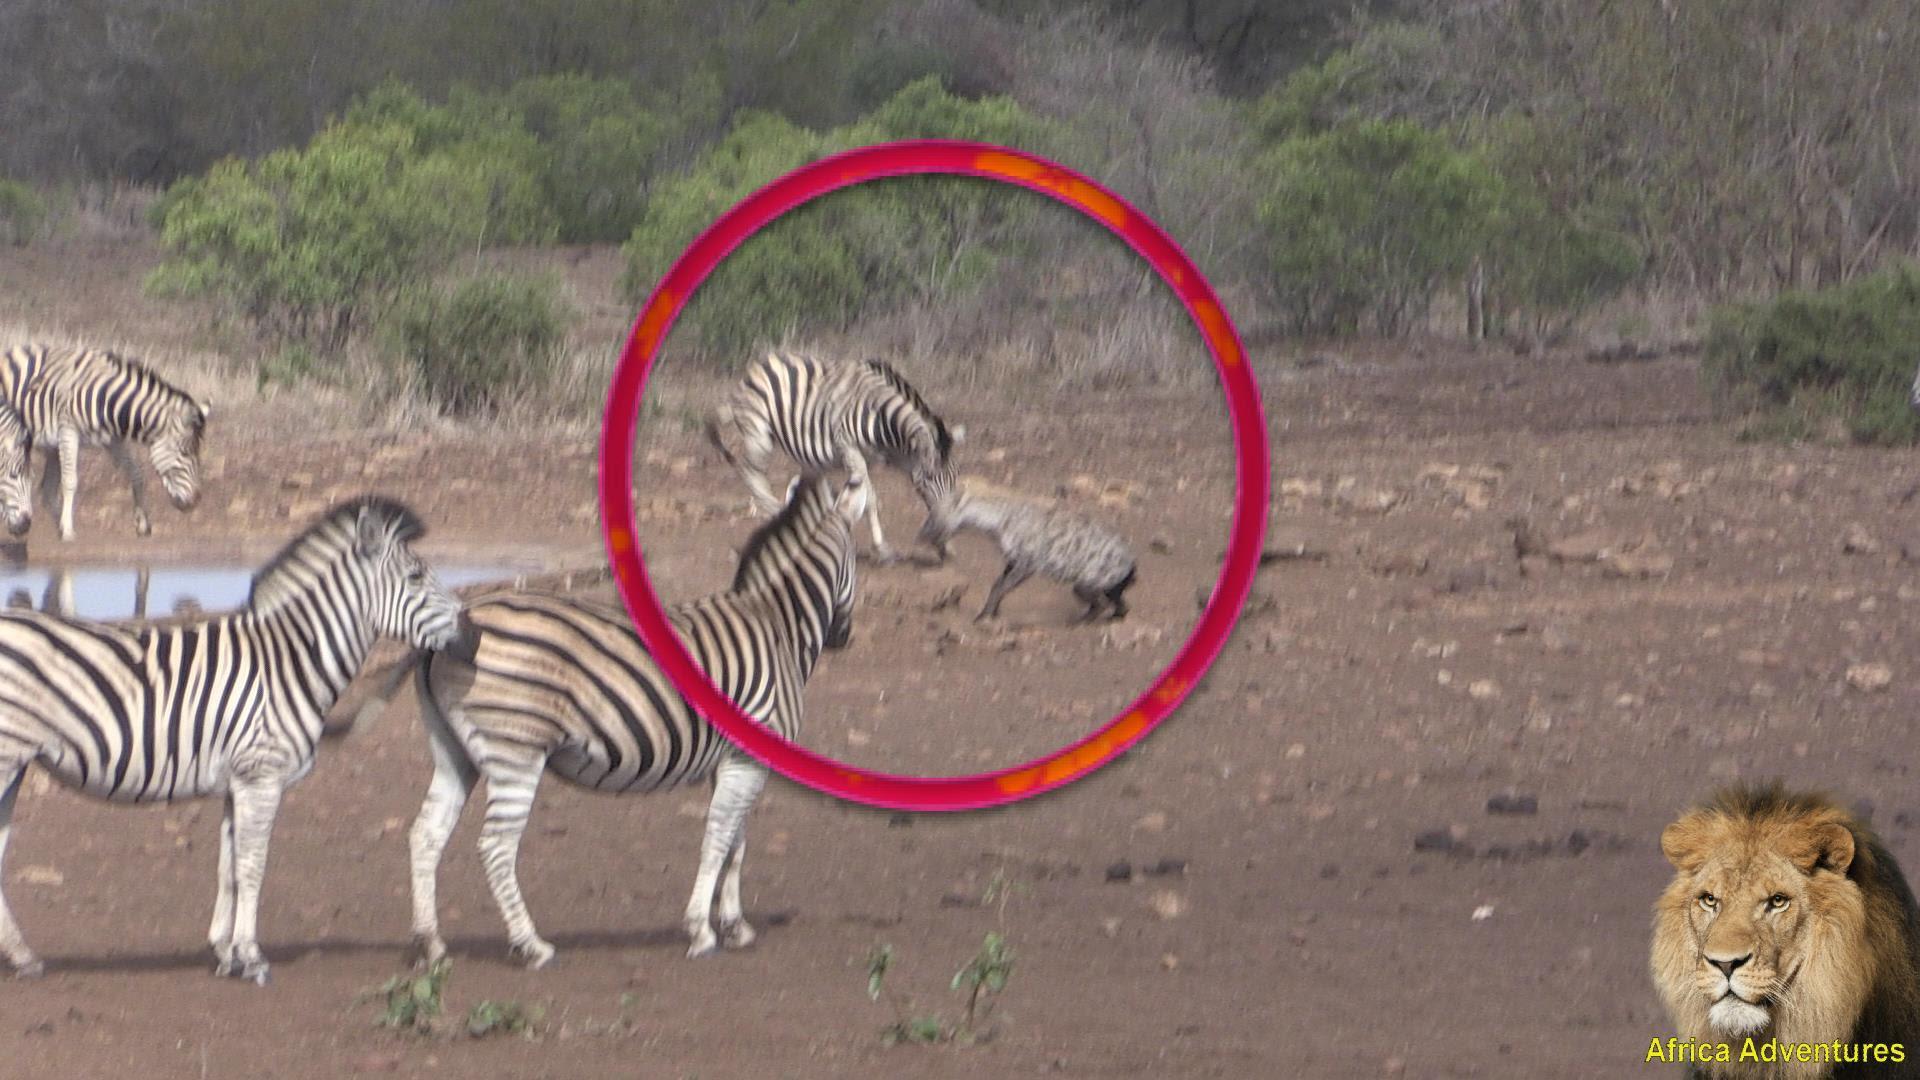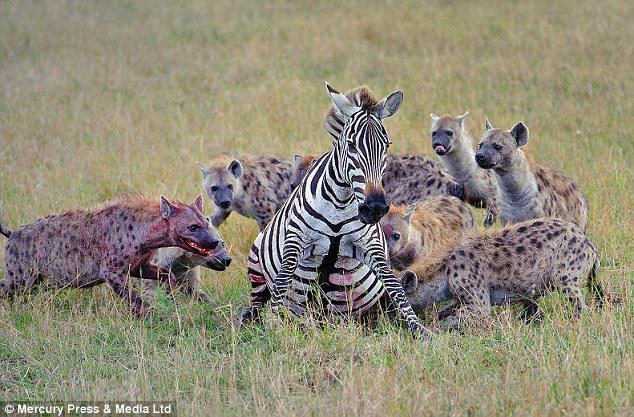The first image is the image on the left, the second image is the image on the right. For the images shown, is this caption "A hyena attacks a zebra that is in the water." true? Answer yes or no. No. 